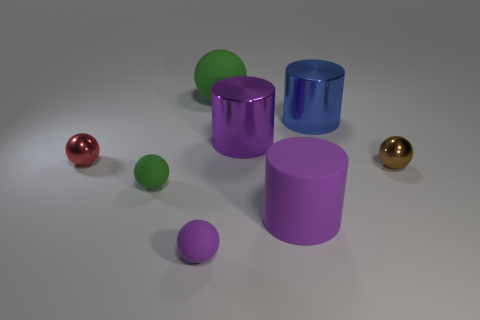Add 1 tiny purple matte cylinders. How many objects exist? 9 Add 4 brown things. How many brown things exist? 5 Subtract all blue cylinders. How many cylinders are left? 2 Subtract all matte cylinders. How many cylinders are left? 2 Subtract 1 blue cylinders. How many objects are left? 7 Subtract all spheres. How many objects are left? 3 Subtract 1 balls. How many balls are left? 4 Subtract all gray cylinders. Subtract all purple spheres. How many cylinders are left? 3 Subtract all cyan spheres. How many blue cylinders are left? 1 Subtract all big red metallic things. Subtract all brown objects. How many objects are left? 7 